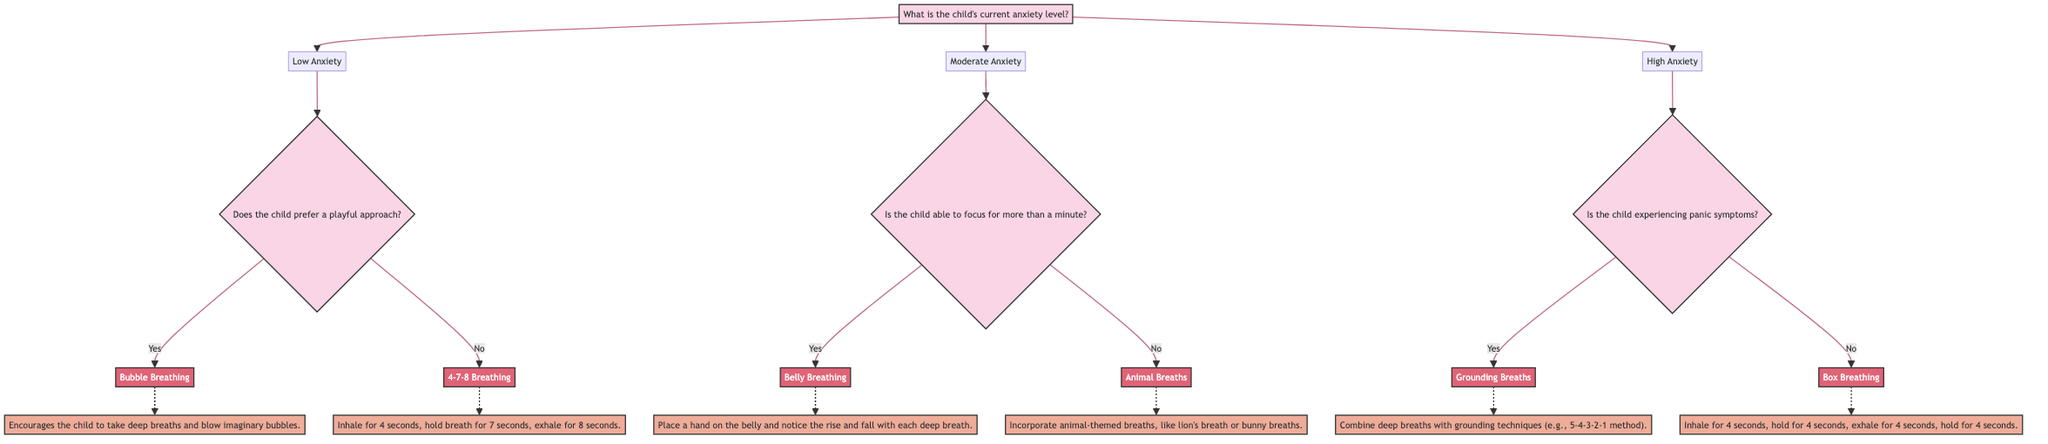What is the first question asked in the diagram? The first question asked in the diagram is about the child's current anxiety level, which branches into Low Anxiety, Moderate Anxiety, and High Anxiety.
Answer: What is the child's current anxiety level? How many branches come from the "Low Anxiety" node? The "Low Anxiety" node has two branches: one for children who prefer a playful approach and one for those who do not.
Answer: Two branches What exercise is recommended for children with Moderate Anxiety who can focus for more than a minute? The recommended exercise for children with Moderate Anxiety who can focus for more than a minute is Belly Breathing. It is explicitly stated in the diagram under that branch.
Answer: Belly Breathing If a child experiences panic symptoms and has High Anxiety, what exercise should they do? If a child has High Anxiety and experiences panic symptoms, the recommended exercise is Grounding Breaths, according to the decision tree structure.
Answer: Grounding Breaths How many different exercises are recommended in the diagram? There are a total of six different exercises recommended in the diagram: Bubble Breathing, 4-7-8 Breathing, Belly Breathing, Animal Breaths, Grounding Breaths, and Box Breathing.
Answer: Six exercises What connection exists between "High Anxiety" and "Box Breathing"? There is a decision that if a child has High Anxiety but does not experience panic symptoms, the exercise recommended is Box Breathing, which connects that specific anxiety level with an appropriate breathing exercise.
Answer: No panic symptoms Which exercise involves blowing imaginary bubbles? The exercise that involves blowing imaginary bubbles is called Bubble Breathing, recommended for children with Low Anxiety who prefer a playful approach.
Answer: Bubble Breathing 